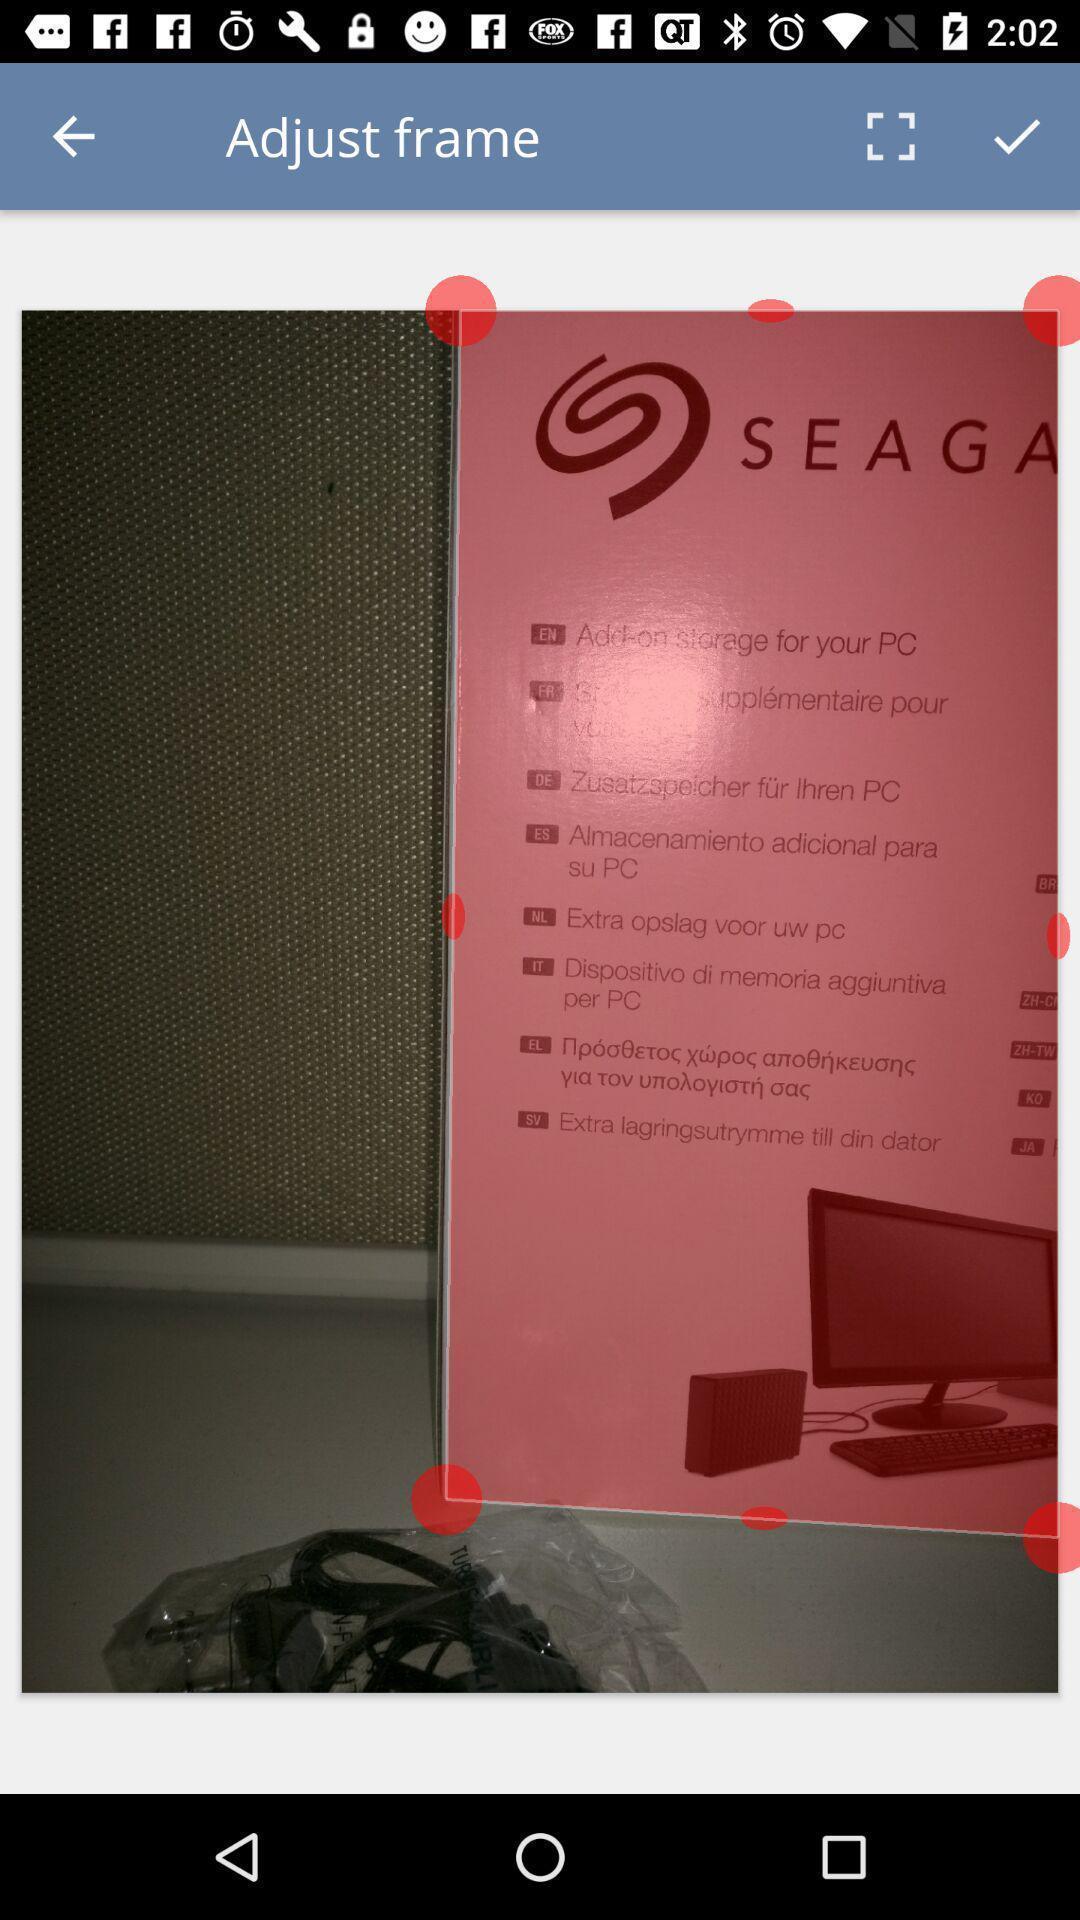Summarize the information in this screenshot. Page cropping an image in a scanning app. 